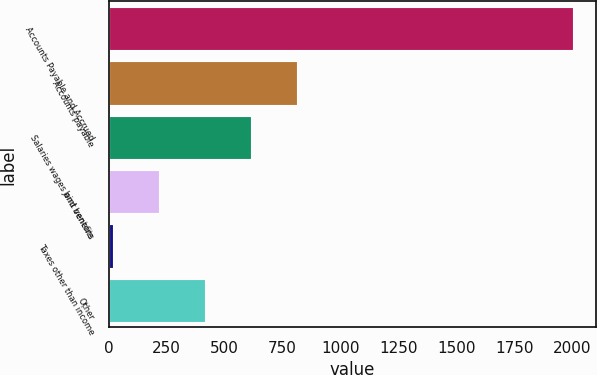Convert chart to OTSL. <chart><loc_0><loc_0><loc_500><loc_500><bar_chart><fcel>Accounts Payable and Accrued<fcel>Accounts payable<fcel>Salaries wages and benefits<fcel>Joint venture<fcel>Taxes other than income<fcel>Other<nl><fcel>2004<fcel>814.02<fcel>615.69<fcel>219.03<fcel>20.7<fcel>417.36<nl></chart> 